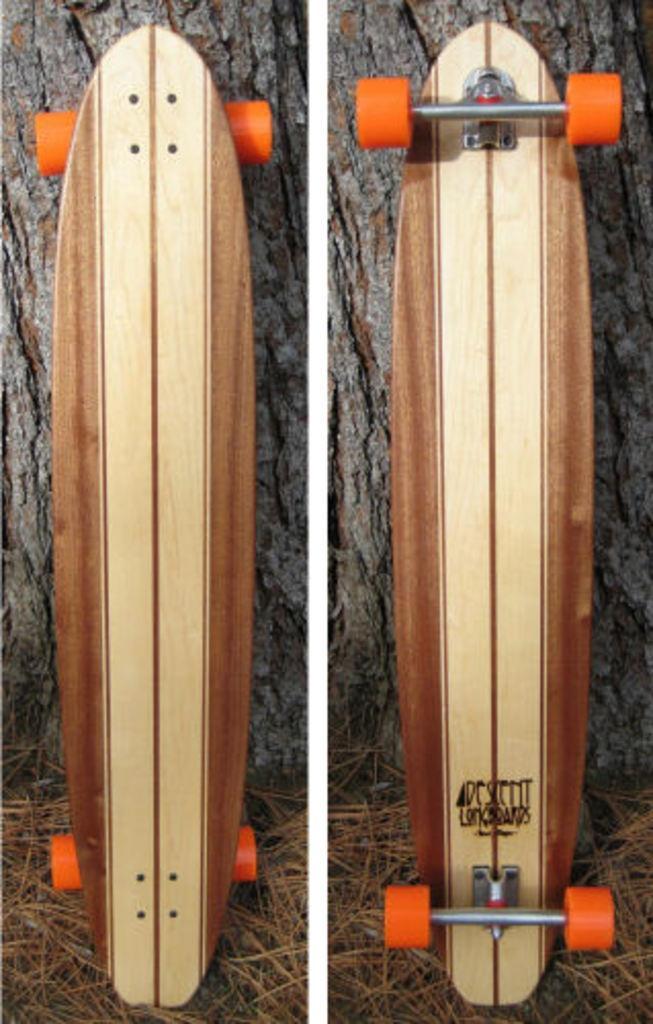Describe this image in one or two sentences. This is a collage image. We can see a skateboard in different angles on the ground. Behind the skateboard, there is a tree trunk. 